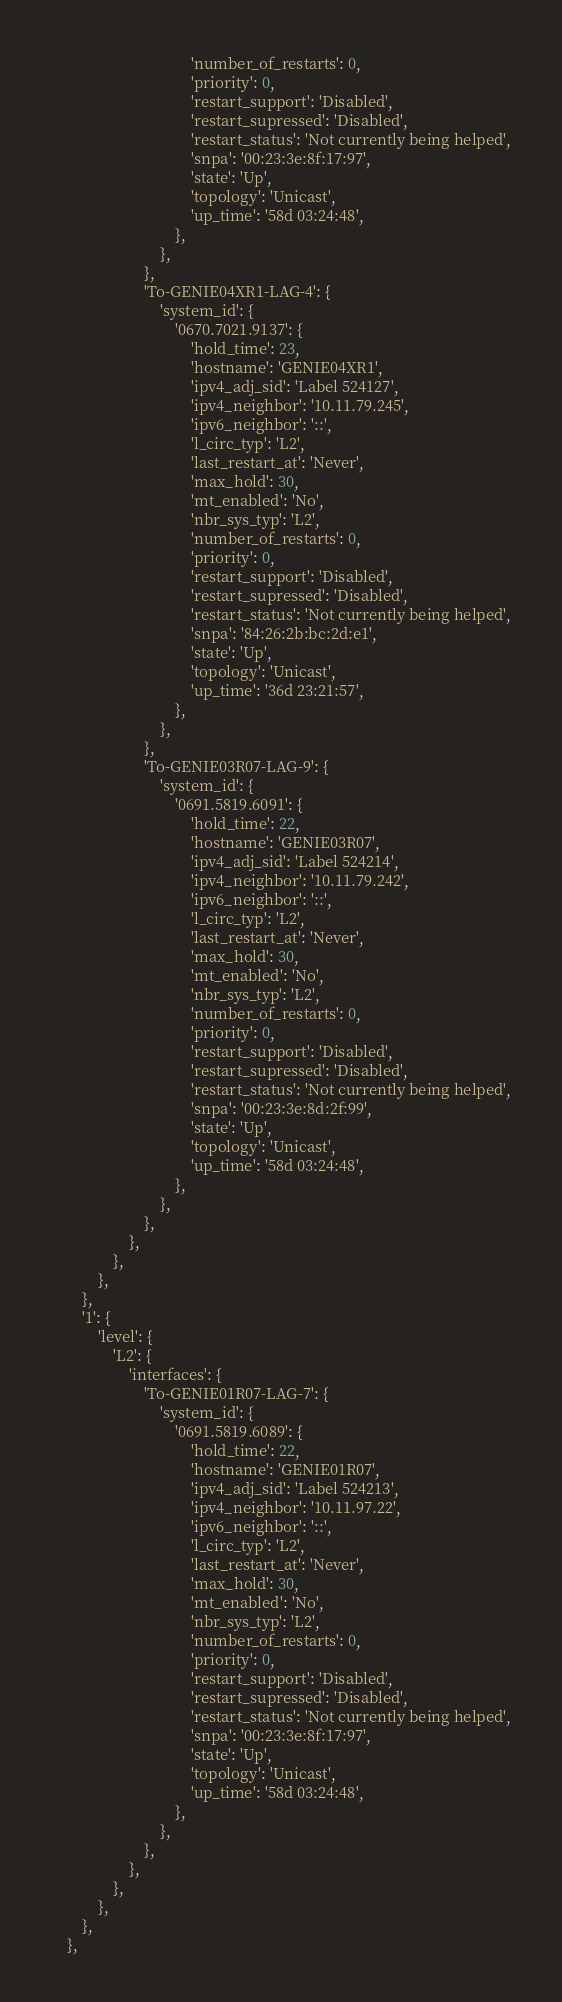Convert code to text. <code><loc_0><loc_0><loc_500><loc_500><_Python_>                                    'number_of_restarts': 0,
                                    'priority': 0,
                                    'restart_support': 'Disabled',
                                    'restart_supressed': 'Disabled',
                                    'restart_status': 'Not currently being helped',
                                    'snpa': '00:23:3e:8f:17:97',
                                    'state': 'Up',
                                    'topology': 'Unicast',
                                    'up_time': '58d 03:24:48',
                                },
                            },
                        },
                        'To-GENIE04XR1-LAG-4': {
                            'system_id': {
                                '0670.7021.9137': {
                                    'hold_time': 23,
                                    'hostname': 'GENIE04XR1',
                                    'ipv4_adj_sid': 'Label 524127',
                                    'ipv4_neighbor': '10.11.79.245',
                                    'ipv6_neighbor': '::',
                                    'l_circ_typ': 'L2',
                                    'last_restart_at': 'Never',
                                    'max_hold': 30,
                                    'mt_enabled': 'No',
                                    'nbr_sys_typ': 'L2',
                                    'number_of_restarts': 0,
                                    'priority': 0,
                                    'restart_support': 'Disabled',
                                    'restart_supressed': 'Disabled',
                                    'restart_status': 'Not currently being helped',
                                    'snpa': '84:26:2b:bc:2d:e1',
                                    'state': 'Up',
                                    'topology': 'Unicast',
                                    'up_time': '36d 23:21:57',
                                },
                            },
                        },
                        'To-GENIE03R07-LAG-9': {
                            'system_id': {
                                '0691.5819.6091': {
                                    'hold_time': 22,
                                    'hostname': 'GENIE03R07',
                                    'ipv4_adj_sid': 'Label 524214',
                                    'ipv4_neighbor': '10.11.79.242',
                                    'ipv6_neighbor': '::',
                                    'l_circ_typ': 'L2',
                                    'last_restart_at': 'Never',
                                    'max_hold': 30,
                                    'mt_enabled': 'No',
                                    'nbr_sys_typ': 'L2',
                                    'number_of_restarts': 0,
                                    'priority': 0,
                                    'restart_support': 'Disabled',
                                    'restart_supressed': 'Disabled',
                                    'restart_status': 'Not currently being helped',
                                    'snpa': '00:23:3e:8d:2f:99',
                                    'state': 'Up',
                                    'topology': 'Unicast',
                                    'up_time': '58d 03:24:48',
                                },
                            },
                        },
                    },
                },
            },
        },
        '1': {
            'level': {
                'L2': {
                    'interfaces': {
                        'To-GENIE01R07-LAG-7': {
                            'system_id': {
                                '0691.5819.6089': {
                                    'hold_time': 22,
                                    'hostname': 'GENIE01R07',
                                    'ipv4_adj_sid': 'Label 524213',
                                    'ipv4_neighbor': '10.11.97.22',
                                    'ipv6_neighbor': '::',
                                    'l_circ_typ': 'L2',
                                    'last_restart_at': 'Never',
                                    'max_hold': 30,
                                    'mt_enabled': 'No',
                                    'nbr_sys_typ': 'L2',
                                    'number_of_restarts': 0,
                                    'priority': 0,
                                    'restart_support': 'Disabled',
                                    'restart_supressed': 'Disabled',
                                    'restart_status': 'Not currently being helped',
                                    'snpa': '00:23:3e:8f:17:97',
                                    'state': 'Up',
                                    'topology': 'Unicast',
                                    'up_time': '58d 03:24:48',
                                },
                            },
                        },
                    },
                },
            },
        },
    },</code> 